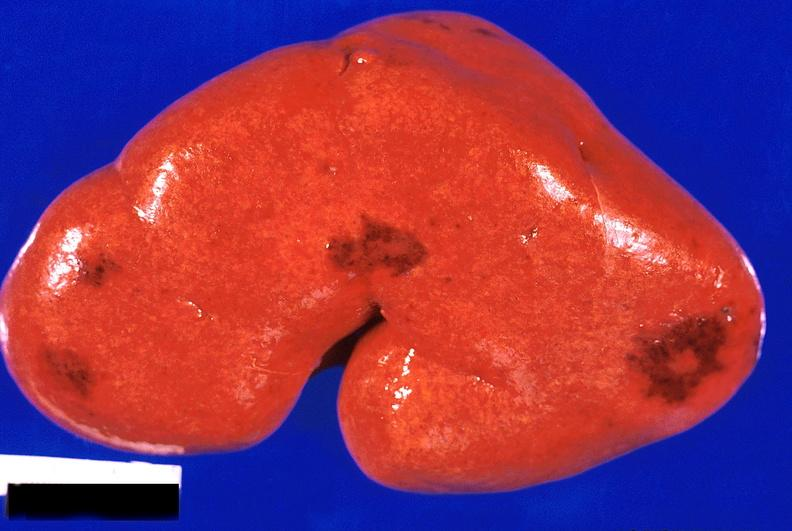where is this?
Answer the question using a single word or phrase. Urinary 